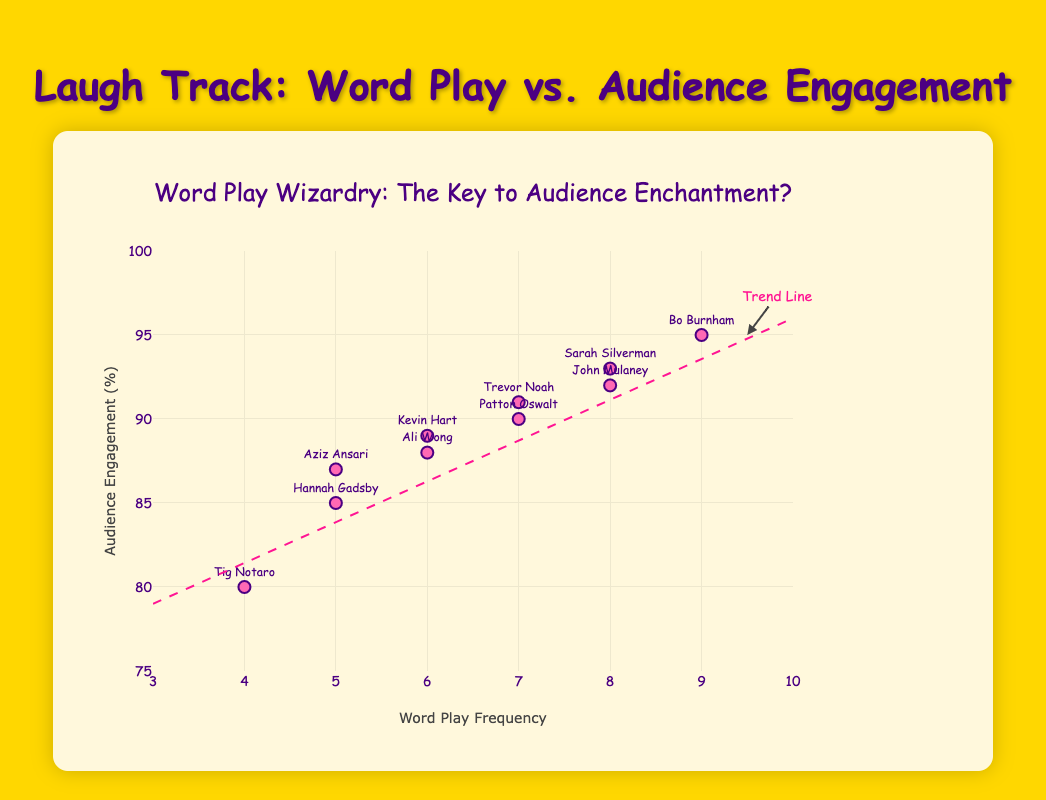What is the title of the chart? The title is the text that appears at the top center of the chart. By looking at the chart, you can see the title printed in large, bold letters.
Answer: Word Play Wizardry: The Key to Audience Enchantment? How many comedians are included in the dataset? Each comedian is represented as an individual data point on the scatter plot. By counting these data points, you can determine the number of comedians.
Answer: 10 Which comedian has the highest audience engagement? The highest point on the y-axis represents the highest audience engagement percentage. By noting the comedian associated with this data point, one can determine who has the highest engagement.
Answer: Bo Burnham What are the x and y axes labeled as? The labels on the x and y axes are the words written along the horizontal and vertical lines of the plot. Inspecting these labels gives the name of the parameters each axis represents.
Answer: Word Play Frequency and Audience Engagement (%) What is the range of audience engagement? The range can be determined by observing the minimum and maximum values labeled on the y-axis. These boundaries represent the span of audience engagement percentages shown in the plot.
Answer: 80% to 95% Compare the engagement of John Mulaney and Sarah Silverman. Who has higher engagement? By finding the data points labeled with "John Mulaney" and "Sarah Silverman" on the scatter plot, one can compare their y-axis values to see which one is higher.
Answer: Sarah Silverman What is the average word play frequency among the comedians? To find the average word play frequency, sum the word play frequency of each comedian and divide by the total number of comedians: (8 + 5 + 9 + 6 + 7 + 4 + 8 + 6 + 5 + 7) / 10 = 65 / 10.
Answer: 6.5 What is the trend line indicating in terms of word play frequency and audience engagement? The trend line shows the general direction and relationship between word play frequency (x-axis) and audience engagement (y-axis). By observing if it slopes upwards or downwards, one can infer positive or negative correlation.
Answer: Positive correlation Which comedians have a word play frequency of 5? By looking for the data points located at the x-value of 5 and checking their associated text labels, one can list the comedians.
Answer: Hannah Gadsby, Aziz Ansari Does higher word play frequency correlate with higher audience engagement? To check for correlation, observe the general direction of data points and the trend line in the scatter plot. If the trend line slopes upward, it indicates a positive correlation.
Answer: Yes 